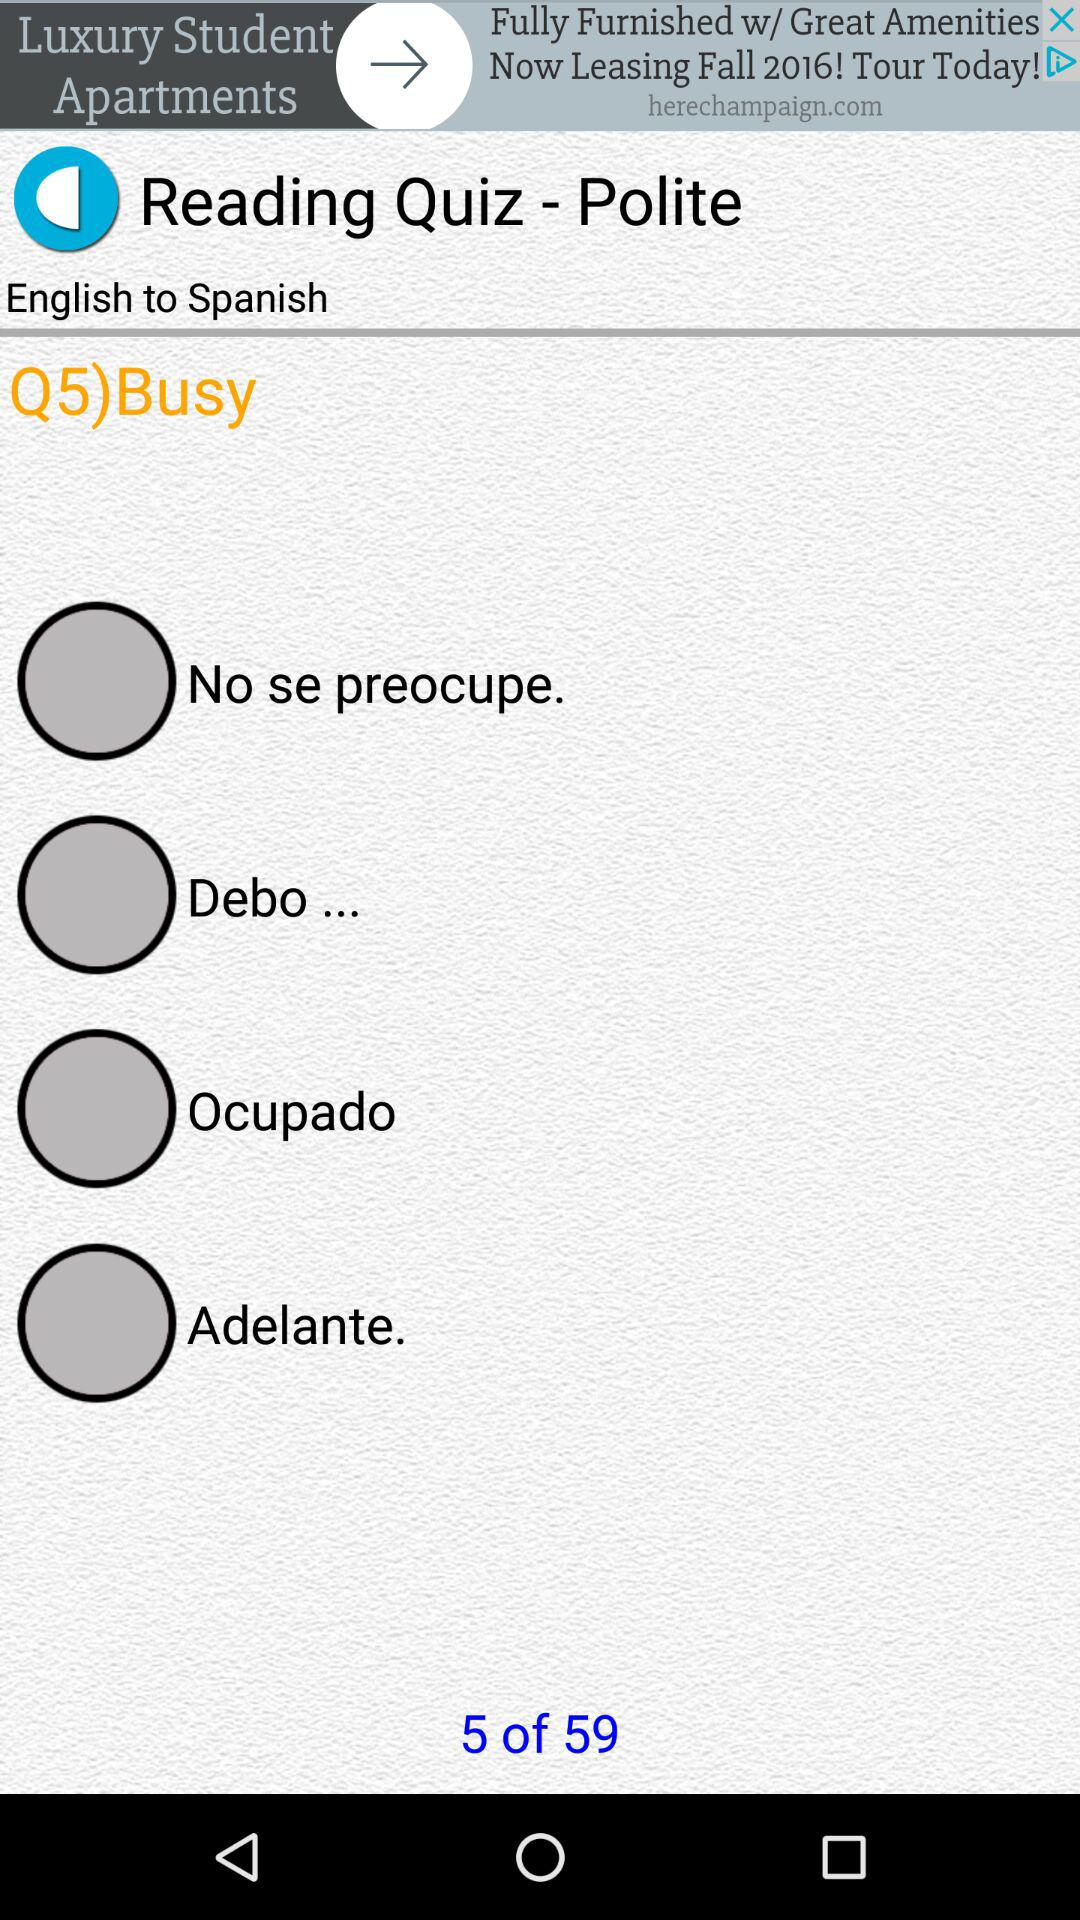What quiz question am I at? You are at question number 5. 